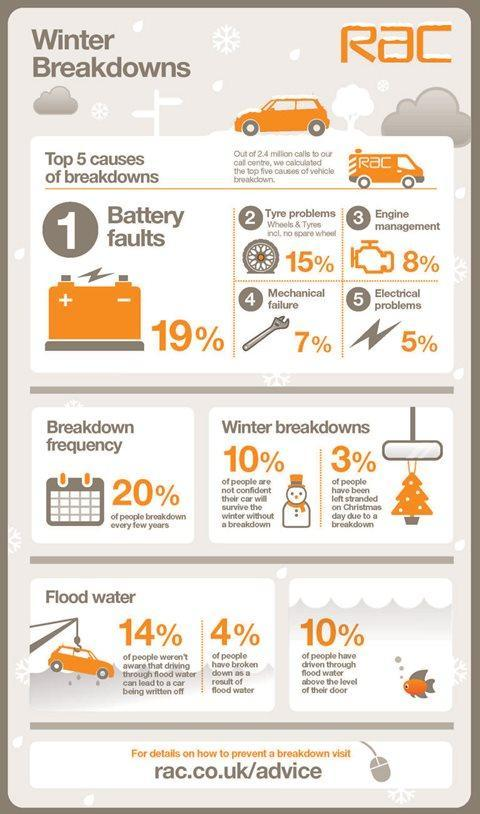What % of people have been left stranded on Christmas due to breakdown
Answer the question with a short phrase. 3 How much total % is the breakdown caused due to mechanical failure and engine management 15 What is written on the van Rac What is the colour of the christmas tree, orange or red orange What % of people were aware that driving through flood water could lead to car being written off 86 What signs are mentioned on the battery +, - What type of breakdown does the spanner indicate Mechnical failure 